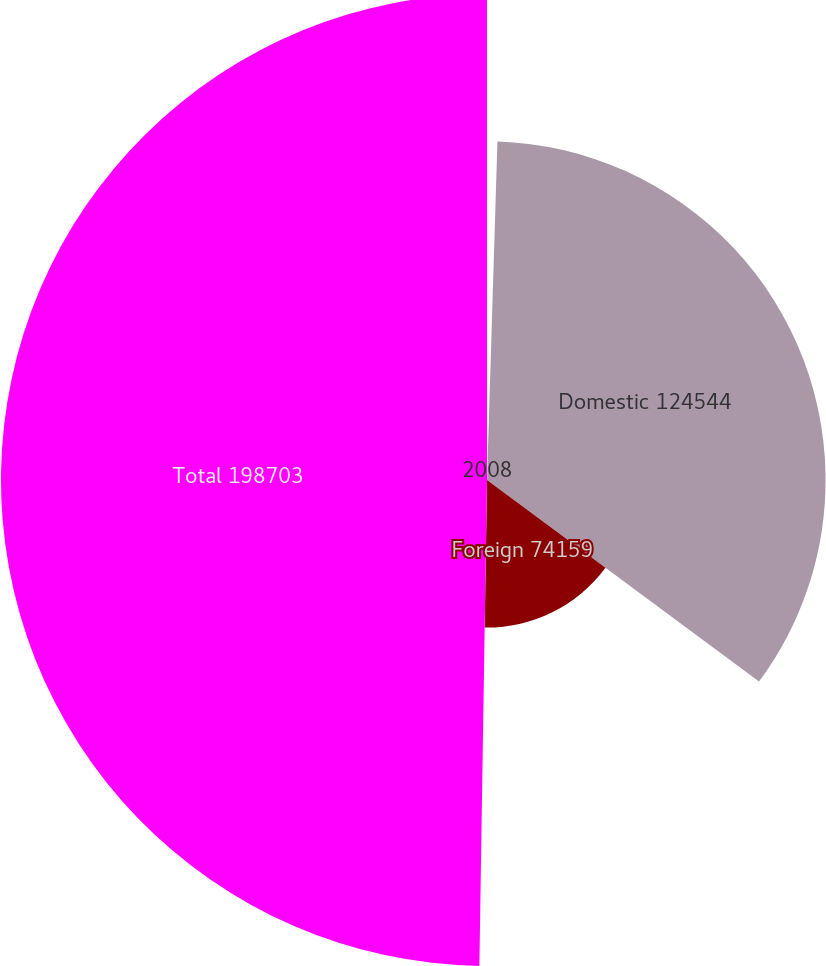Convert chart to OTSL. <chart><loc_0><loc_0><loc_500><loc_500><pie_chart><fcel>2008<fcel>Domestic 124544<fcel>Foreign 74159<fcel>Total 198703<nl><fcel>0.49%<fcel>34.66%<fcel>15.1%<fcel>49.75%<nl></chart> 